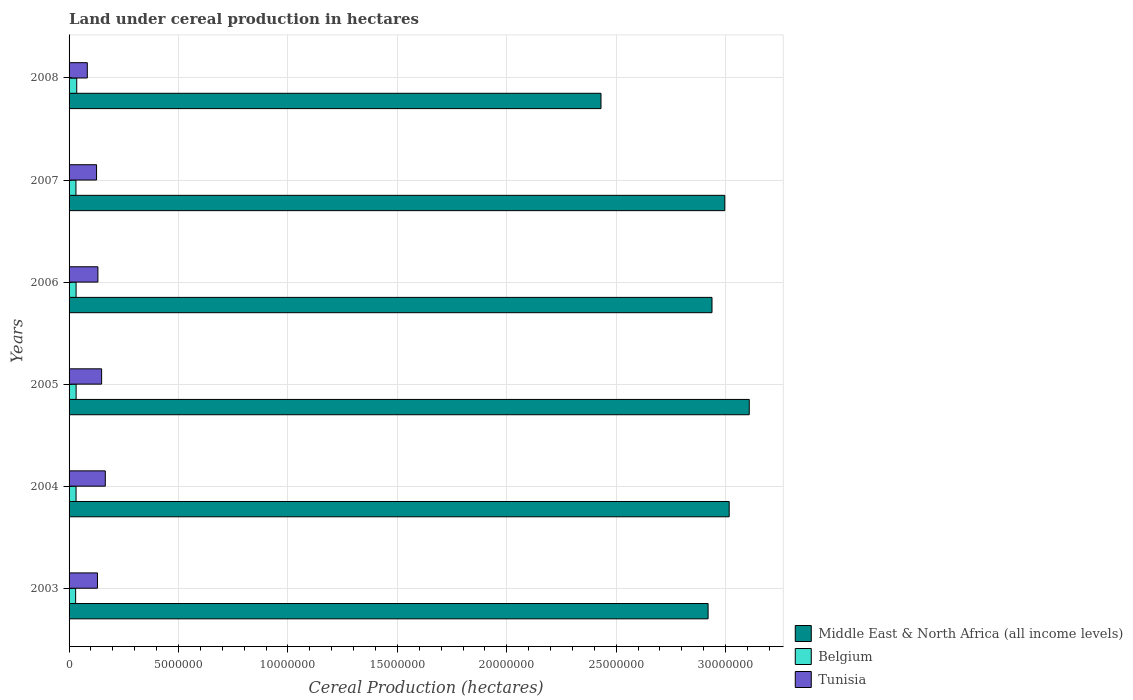Are the number of bars per tick equal to the number of legend labels?
Keep it short and to the point. Yes. Are the number of bars on each tick of the Y-axis equal?
Your response must be concise. Yes. How many bars are there on the 6th tick from the top?
Offer a terse response. 3. How many bars are there on the 4th tick from the bottom?
Keep it short and to the point. 3. What is the label of the 6th group of bars from the top?
Offer a very short reply. 2003. What is the land under cereal production in Middle East & North Africa (all income levels) in 2005?
Your response must be concise. 3.11e+07. Across all years, what is the maximum land under cereal production in Middle East & North Africa (all income levels)?
Provide a short and direct response. 3.11e+07. Across all years, what is the minimum land under cereal production in Middle East & North Africa (all income levels)?
Provide a short and direct response. 2.43e+07. In which year was the land under cereal production in Middle East & North Africa (all income levels) maximum?
Give a very brief answer. 2005. In which year was the land under cereal production in Tunisia minimum?
Offer a very short reply. 2008. What is the total land under cereal production in Tunisia in the graph?
Ensure brevity in your answer.  7.85e+06. What is the difference between the land under cereal production in Tunisia in 2007 and that in 2008?
Provide a succinct answer. 4.22e+05. What is the difference between the land under cereal production in Middle East & North Africa (all income levels) in 2004 and the land under cereal production in Tunisia in 2007?
Your answer should be very brief. 2.89e+07. What is the average land under cereal production in Middle East & North Africa (all income levels) per year?
Your response must be concise. 2.90e+07. In the year 2006, what is the difference between the land under cereal production in Tunisia and land under cereal production in Belgium?
Offer a terse response. 9.97e+05. In how many years, is the land under cereal production in Tunisia greater than 27000000 hectares?
Make the answer very short. 0. What is the ratio of the land under cereal production in Belgium in 2003 to that in 2007?
Provide a short and direct response. 0.95. Is the land under cereal production in Belgium in 2004 less than that in 2008?
Keep it short and to the point. Yes. Is the difference between the land under cereal production in Tunisia in 2003 and 2004 greater than the difference between the land under cereal production in Belgium in 2003 and 2004?
Provide a short and direct response. No. What is the difference between the highest and the second highest land under cereal production in Middle East & North Africa (all income levels)?
Give a very brief answer. 9.17e+05. What is the difference between the highest and the lowest land under cereal production in Middle East & North Africa (all income levels)?
Ensure brevity in your answer.  6.77e+06. Is the sum of the land under cereal production in Middle East & North Africa (all income levels) in 2004 and 2006 greater than the maximum land under cereal production in Belgium across all years?
Ensure brevity in your answer.  Yes. What does the 1st bar from the top in 2003 represents?
Offer a very short reply. Tunisia. What does the 3rd bar from the bottom in 2006 represents?
Offer a terse response. Tunisia. Is it the case that in every year, the sum of the land under cereal production in Middle East & North Africa (all income levels) and land under cereal production in Belgium is greater than the land under cereal production in Tunisia?
Make the answer very short. Yes. Are all the bars in the graph horizontal?
Provide a succinct answer. Yes. Does the graph contain any zero values?
Give a very brief answer. No. Does the graph contain grids?
Provide a succinct answer. Yes. What is the title of the graph?
Give a very brief answer. Land under cereal production in hectares. What is the label or title of the X-axis?
Provide a succinct answer. Cereal Production (hectares). What is the Cereal Production (hectares) of Middle East & North Africa (all income levels) in 2003?
Provide a succinct answer. 2.92e+07. What is the Cereal Production (hectares) in Belgium in 2003?
Offer a very short reply. 3.00e+05. What is the Cereal Production (hectares) in Tunisia in 2003?
Give a very brief answer. 1.30e+06. What is the Cereal Production (hectares) in Middle East & North Africa (all income levels) in 2004?
Provide a short and direct response. 3.02e+07. What is the Cereal Production (hectares) in Belgium in 2004?
Offer a very short reply. 3.19e+05. What is the Cereal Production (hectares) in Tunisia in 2004?
Provide a succinct answer. 1.65e+06. What is the Cereal Production (hectares) in Middle East & North Africa (all income levels) in 2005?
Your answer should be very brief. 3.11e+07. What is the Cereal Production (hectares) in Belgium in 2005?
Your response must be concise. 3.22e+05. What is the Cereal Production (hectares) of Tunisia in 2005?
Offer a very short reply. 1.49e+06. What is the Cereal Production (hectares) in Middle East & North Africa (all income levels) in 2006?
Provide a short and direct response. 2.94e+07. What is the Cereal Production (hectares) in Belgium in 2006?
Ensure brevity in your answer.  3.21e+05. What is the Cereal Production (hectares) of Tunisia in 2006?
Your answer should be compact. 1.32e+06. What is the Cereal Production (hectares) of Middle East & North Africa (all income levels) in 2007?
Your answer should be very brief. 3.00e+07. What is the Cereal Production (hectares) in Belgium in 2007?
Make the answer very short. 3.15e+05. What is the Cereal Production (hectares) of Tunisia in 2007?
Keep it short and to the point. 1.26e+06. What is the Cereal Production (hectares) of Middle East & North Africa (all income levels) in 2008?
Your answer should be very brief. 2.43e+07. What is the Cereal Production (hectares) of Belgium in 2008?
Your answer should be compact. 3.50e+05. What is the Cereal Production (hectares) of Tunisia in 2008?
Give a very brief answer. 8.34e+05. Across all years, what is the maximum Cereal Production (hectares) in Middle East & North Africa (all income levels)?
Ensure brevity in your answer.  3.11e+07. Across all years, what is the maximum Cereal Production (hectares) of Belgium?
Ensure brevity in your answer.  3.50e+05. Across all years, what is the maximum Cereal Production (hectares) in Tunisia?
Your answer should be very brief. 1.65e+06. Across all years, what is the minimum Cereal Production (hectares) in Middle East & North Africa (all income levels)?
Your answer should be very brief. 2.43e+07. Across all years, what is the minimum Cereal Production (hectares) in Belgium?
Your answer should be very brief. 3.00e+05. Across all years, what is the minimum Cereal Production (hectares) in Tunisia?
Provide a short and direct response. 8.34e+05. What is the total Cereal Production (hectares) in Middle East & North Africa (all income levels) in the graph?
Give a very brief answer. 1.74e+08. What is the total Cereal Production (hectares) in Belgium in the graph?
Keep it short and to the point. 1.93e+06. What is the total Cereal Production (hectares) in Tunisia in the graph?
Give a very brief answer. 7.85e+06. What is the difference between the Cereal Production (hectares) of Middle East & North Africa (all income levels) in 2003 and that in 2004?
Offer a terse response. -9.64e+05. What is the difference between the Cereal Production (hectares) of Belgium in 2003 and that in 2004?
Provide a succinct answer. -1.90e+04. What is the difference between the Cereal Production (hectares) in Tunisia in 2003 and that in 2004?
Ensure brevity in your answer.  -3.57e+05. What is the difference between the Cereal Production (hectares) in Middle East & North Africa (all income levels) in 2003 and that in 2005?
Provide a short and direct response. -1.88e+06. What is the difference between the Cereal Production (hectares) of Belgium in 2003 and that in 2005?
Ensure brevity in your answer.  -2.20e+04. What is the difference between the Cereal Production (hectares) in Tunisia in 2003 and that in 2005?
Your response must be concise. -1.90e+05. What is the difference between the Cereal Production (hectares) of Middle East & North Africa (all income levels) in 2003 and that in 2006?
Your answer should be very brief. -1.78e+05. What is the difference between the Cereal Production (hectares) of Belgium in 2003 and that in 2006?
Make the answer very short. -2.04e+04. What is the difference between the Cereal Production (hectares) in Tunisia in 2003 and that in 2006?
Offer a terse response. -1.98e+04. What is the difference between the Cereal Production (hectares) of Middle East & North Africa (all income levels) in 2003 and that in 2007?
Your answer should be compact. -7.63e+05. What is the difference between the Cereal Production (hectares) in Belgium in 2003 and that in 2007?
Offer a terse response. -1.45e+04. What is the difference between the Cereal Production (hectares) of Tunisia in 2003 and that in 2007?
Give a very brief answer. 4.20e+04. What is the difference between the Cereal Production (hectares) of Middle East & North Africa (all income levels) in 2003 and that in 2008?
Give a very brief answer. 4.89e+06. What is the difference between the Cereal Production (hectares) of Belgium in 2003 and that in 2008?
Your response must be concise. -5.02e+04. What is the difference between the Cereal Production (hectares) in Tunisia in 2003 and that in 2008?
Ensure brevity in your answer.  4.64e+05. What is the difference between the Cereal Production (hectares) of Middle East & North Africa (all income levels) in 2004 and that in 2005?
Provide a succinct answer. -9.17e+05. What is the difference between the Cereal Production (hectares) of Belgium in 2004 and that in 2005?
Your response must be concise. -2948. What is the difference between the Cereal Production (hectares) of Tunisia in 2004 and that in 2005?
Your response must be concise. 1.68e+05. What is the difference between the Cereal Production (hectares) in Middle East & North Africa (all income levels) in 2004 and that in 2006?
Provide a succinct answer. 7.85e+05. What is the difference between the Cereal Production (hectares) in Belgium in 2004 and that in 2006?
Your response must be concise. -1352. What is the difference between the Cereal Production (hectares) in Tunisia in 2004 and that in 2006?
Your answer should be very brief. 3.37e+05. What is the difference between the Cereal Production (hectares) of Middle East & North Africa (all income levels) in 2004 and that in 2007?
Provide a succinct answer. 2.01e+05. What is the difference between the Cereal Production (hectares) in Belgium in 2004 and that in 2007?
Your response must be concise. 4467. What is the difference between the Cereal Production (hectares) in Tunisia in 2004 and that in 2007?
Provide a succinct answer. 3.99e+05. What is the difference between the Cereal Production (hectares) of Middle East & North Africa (all income levels) in 2004 and that in 2008?
Your answer should be compact. 5.86e+06. What is the difference between the Cereal Production (hectares) of Belgium in 2004 and that in 2008?
Offer a terse response. -3.11e+04. What is the difference between the Cereal Production (hectares) of Tunisia in 2004 and that in 2008?
Keep it short and to the point. 8.21e+05. What is the difference between the Cereal Production (hectares) of Middle East & North Africa (all income levels) in 2005 and that in 2006?
Provide a succinct answer. 1.70e+06. What is the difference between the Cereal Production (hectares) in Belgium in 2005 and that in 2006?
Provide a succinct answer. 1596. What is the difference between the Cereal Production (hectares) in Tunisia in 2005 and that in 2006?
Offer a very short reply. 1.70e+05. What is the difference between the Cereal Production (hectares) of Middle East & North Africa (all income levels) in 2005 and that in 2007?
Your response must be concise. 1.12e+06. What is the difference between the Cereal Production (hectares) in Belgium in 2005 and that in 2007?
Make the answer very short. 7415. What is the difference between the Cereal Production (hectares) of Tunisia in 2005 and that in 2007?
Provide a succinct answer. 2.31e+05. What is the difference between the Cereal Production (hectares) in Middle East & North Africa (all income levels) in 2005 and that in 2008?
Offer a very short reply. 6.77e+06. What is the difference between the Cereal Production (hectares) of Belgium in 2005 and that in 2008?
Give a very brief answer. -2.82e+04. What is the difference between the Cereal Production (hectares) of Tunisia in 2005 and that in 2008?
Provide a succinct answer. 6.54e+05. What is the difference between the Cereal Production (hectares) in Middle East & North Africa (all income levels) in 2006 and that in 2007?
Offer a very short reply. -5.85e+05. What is the difference between the Cereal Production (hectares) of Belgium in 2006 and that in 2007?
Keep it short and to the point. 5819. What is the difference between the Cereal Production (hectares) in Tunisia in 2006 and that in 2007?
Your response must be concise. 6.18e+04. What is the difference between the Cereal Production (hectares) in Middle East & North Africa (all income levels) in 2006 and that in 2008?
Ensure brevity in your answer.  5.07e+06. What is the difference between the Cereal Production (hectares) in Belgium in 2006 and that in 2008?
Your answer should be very brief. -2.98e+04. What is the difference between the Cereal Production (hectares) of Tunisia in 2006 and that in 2008?
Offer a very short reply. 4.84e+05. What is the difference between the Cereal Production (hectares) in Middle East & North Africa (all income levels) in 2007 and that in 2008?
Offer a very short reply. 5.66e+06. What is the difference between the Cereal Production (hectares) of Belgium in 2007 and that in 2008?
Your answer should be very brief. -3.56e+04. What is the difference between the Cereal Production (hectares) of Tunisia in 2007 and that in 2008?
Offer a very short reply. 4.22e+05. What is the difference between the Cereal Production (hectares) in Middle East & North Africa (all income levels) in 2003 and the Cereal Production (hectares) in Belgium in 2004?
Offer a very short reply. 2.89e+07. What is the difference between the Cereal Production (hectares) in Middle East & North Africa (all income levels) in 2003 and the Cereal Production (hectares) in Tunisia in 2004?
Your response must be concise. 2.75e+07. What is the difference between the Cereal Production (hectares) of Belgium in 2003 and the Cereal Production (hectares) of Tunisia in 2004?
Offer a very short reply. -1.35e+06. What is the difference between the Cereal Production (hectares) of Middle East & North Africa (all income levels) in 2003 and the Cereal Production (hectares) of Belgium in 2005?
Keep it short and to the point. 2.89e+07. What is the difference between the Cereal Production (hectares) in Middle East & North Africa (all income levels) in 2003 and the Cereal Production (hectares) in Tunisia in 2005?
Provide a short and direct response. 2.77e+07. What is the difference between the Cereal Production (hectares) in Belgium in 2003 and the Cereal Production (hectares) in Tunisia in 2005?
Your answer should be compact. -1.19e+06. What is the difference between the Cereal Production (hectares) of Middle East & North Africa (all income levels) in 2003 and the Cereal Production (hectares) of Belgium in 2006?
Ensure brevity in your answer.  2.89e+07. What is the difference between the Cereal Production (hectares) in Middle East & North Africa (all income levels) in 2003 and the Cereal Production (hectares) in Tunisia in 2006?
Offer a very short reply. 2.79e+07. What is the difference between the Cereal Production (hectares) in Belgium in 2003 and the Cereal Production (hectares) in Tunisia in 2006?
Ensure brevity in your answer.  -1.02e+06. What is the difference between the Cereal Production (hectares) in Middle East & North Africa (all income levels) in 2003 and the Cereal Production (hectares) in Belgium in 2007?
Provide a short and direct response. 2.89e+07. What is the difference between the Cereal Production (hectares) of Middle East & North Africa (all income levels) in 2003 and the Cereal Production (hectares) of Tunisia in 2007?
Give a very brief answer. 2.79e+07. What is the difference between the Cereal Production (hectares) in Belgium in 2003 and the Cereal Production (hectares) in Tunisia in 2007?
Provide a succinct answer. -9.56e+05. What is the difference between the Cereal Production (hectares) of Middle East & North Africa (all income levels) in 2003 and the Cereal Production (hectares) of Belgium in 2008?
Offer a very short reply. 2.88e+07. What is the difference between the Cereal Production (hectares) of Middle East & North Africa (all income levels) in 2003 and the Cereal Production (hectares) of Tunisia in 2008?
Keep it short and to the point. 2.84e+07. What is the difference between the Cereal Production (hectares) in Belgium in 2003 and the Cereal Production (hectares) in Tunisia in 2008?
Your answer should be very brief. -5.33e+05. What is the difference between the Cereal Production (hectares) in Middle East & North Africa (all income levels) in 2004 and the Cereal Production (hectares) in Belgium in 2005?
Your answer should be compact. 2.98e+07. What is the difference between the Cereal Production (hectares) of Middle East & North Africa (all income levels) in 2004 and the Cereal Production (hectares) of Tunisia in 2005?
Give a very brief answer. 2.87e+07. What is the difference between the Cereal Production (hectares) in Belgium in 2004 and the Cereal Production (hectares) in Tunisia in 2005?
Give a very brief answer. -1.17e+06. What is the difference between the Cereal Production (hectares) in Middle East & North Africa (all income levels) in 2004 and the Cereal Production (hectares) in Belgium in 2006?
Ensure brevity in your answer.  2.98e+07. What is the difference between the Cereal Production (hectares) in Middle East & North Africa (all income levels) in 2004 and the Cereal Production (hectares) in Tunisia in 2006?
Keep it short and to the point. 2.88e+07. What is the difference between the Cereal Production (hectares) in Belgium in 2004 and the Cereal Production (hectares) in Tunisia in 2006?
Make the answer very short. -9.98e+05. What is the difference between the Cereal Production (hectares) in Middle East & North Africa (all income levels) in 2004 and the Cereal Production (hectares) in Belgium in 2007?
Keep it short and to the point. 2.98e+07. What is the difference between the Cereal Production (hectares) of Middle East & North Africa (all income levels) in 2004 and the Cereal Production (hectares) of Tunisia in 2007?
Give a very brief answer. 2.89e+07. What is the difference between the Cereal Production (hectares) in Belgium in 2004 and the Cereal Production (hectares) in Tunisia in 2007?
Ensure brevity in your answer.  -9.37e+05. What is the difference between the Cereal Production (hectares) in Middle East & North Africa (all income levels) in 2004 and the Cereal Production (hectares) in Belgium in 2008?
Your answer should be very brief. 2.98e+07. What is the difference between the Cereal Production (hectares) of Middle East & North Africa (all income levels) in 2004 and the Cereal Production (hectares) of Tunisia in 2008?
Make the answer very short. 2.93e+07. What is the difference between the Cereal Production (hectares) of Belgium in 2004 and the Cereal Production (hectares) of Tunisia in 2008?
Ensure brevity in your answer.  -5.14e+05. What is the difference between the Cereal Production (hectares) of Middle East & North Africa (all income levels) in 2005 and the Cereal Production (hectares) of Belgium in 2006?
Provide a succinct answer. 3.08e+07. What is the difference between the Cereal Production (hectares) of Middle East & North Africa (all income levels) in 2005 and the Cereal Production (hectares) of Tunisia in 2006?
Offer a very short reply. 2.98e+07. What is the difference between the Cereal Production (hectares) in Belgium in 2005 and the Cereal Production (hectares) in Tunisia in 2006?
Offer a terse response. -9.96e+05. What is the difference between the Cereal Production (hectares) in Middle East & North Africa (all income levels) in 2005 and the Cereal Production (hectares) in Belgium in 2007?
Keep it short and to the point. 3.08e+07. What is the difference between the Cereal Production (hectares) of Middle East & North Africa (all income levels) in 2005 and the Cereal Production (hectares) of Tunisia in 2007?
Your response must be concise. 2.98e+07. What is the difference between the Cereal Production (hectares) in Belgium in 2005 and the Cereal Production (hectares) in Tunisia in 2007?
Offer a terse response. -9.34e+05. What is the difference between the Cereal Production (hectares) in Middle East & North Africa (all income levels) in 2005 and the Cereal Production (hectares) in Belgium in 2008?
Provide a succinct answer. 3.07e+07. What is the difference between the Cereal Production (hectares) of Middle East & North Africa (all income levels) in 2005 and the Cereal Production (hectares) of Tunisia in 2008?
Your answer should be very brief. 3.02e+07. What is the difference between the Cereal Production (hectares) in Belgium in 2005 and the Cereal Production (hectares) in Tunisia in 2008?
Your answer should be very brief. -5.12e+05. What is the difference between the Cereal Production (hectares) of Middle East & North Africa (all income levels) in 2006 and the Cereal Production (hectares) of Belgium in 2007?
Offer a very short reply. 2.91e+07. What is the difference between the Cereal Production (hectares) of Middle East & North Africa (all income levels) in 2006 and the Cereal Production (hectares) of Tunisia in 2007?
Your answer should be very brief. 2.81e+07. What is the difference between the Cereal Production (hectares) of Belgium in 2006 and the Cereal Production (hectares) of Tunisia in 2007?
Your answer should be compact. -9.35e+05. What is the difference between the Cereal Production (hectares) of Middle East & North Africa (all income levels) in 2006 and the Cereal Production (hectares) of Belgium in 2008?
Provide a succinct answer. 2.90e+07. What is the difference between the Cereal Production (hectares) in Middle East & North Africa (all income levels) in 2006 and the Cereal Production (hectares) in Tunisia in 2008?
Provide a succinct answer. 2.85e+07. What is the difference between the Cereal Production (hectares) in Belgium in 2006 and the Cereal Production (hectares) in Tunisia in 2008?
Provide a short and direct response. -5.13e+05. What is the difference between the Cereal Production (hectares) of Middle East & North Africa (all income levels) in 2007 and the Cereal Production (hectares) of Belgium in 2008?
Offer a very short reply. 2.96e+07. What is the difference between the Cereal Production (hectares) in Middle East & North Africa (all income levels) in 2007 and the Cereal Production (hectares) in Tunisia in 2008?
Offer a terse response. 2.91e+07. What is the difference between the Cereal Production (hectares) in Belgium in 2007 and the Cereal Production (hectares) in Tunisia in 2008?
Your response must be concise. -5.19e+05. What is the average Cereal Production (hectares) in Middle East & North Africa (all income levels) per year?
Offer a very short reply. 2.90e+07. What is the average Cereal Production (hectares) in Belgium per year?
Keep it short and to the point. 3.21e+05. What is the average Cereal Production (hectares) of Tunisia per year?
Provide a short and direct response. 1.31e+06. In the year 2003, what is the difference between the Cereal Production (hectares) of Middle East & North Africa (all income levels) and Cereal Production (hectares) of Belgium?
Your answer should be very brief. 2.89e+07. In the year 2003, what is the difference between the Cereal Production (hectares) in Middle East & North Africa (all income levels) and Cereal Production (hectares) in Tunisia?
Offer a terse response. 2.79e+07. In the year 2003, what is the difference between the Cereal Production (hectares) in Belgium and Cereal Production (hectares) in Tunisia?
Provide a short and direct response. -9.98e+05. In the year 2004, what is the difference between the Cereal Production (hectares) of Middle East & North Africa (all income levels) and Cereal Production (hectares) of Belgium?
Make the answer very short. 2.98e+07. In the year 2004, what is the difference between the Cereal Production (hectares) in Middle East & North Africa (all income levels) and Cereal Production (hectares) in Tunisia?
Ensure brevity in your answer.  2.85e+07. In the year 2004, what is the difference between the Cereal Production (hectares) of Belgium and Cereal Production (hectares) of Tunisia?
Provide a short and direct response. -1.34e+06. In the year 2005, what is the difference between the Cereal Production (hectares) in Middle East & North Africa (all income levels) and Cereal Production (hectares) in Belgium?
Provide a short and direct response. 3.08e+07. In the year 2005, what is the difference between the Cereal Production (hectares) of Middle East & North Africa (all income levels) and Cereal Production (hectares) of Tunisia?
Your answer should be compact. 2.96e+07. In the year 2005, what is the difference between the Cereal Production (hectares) of Belgium and Cereal Production (hectares) of Tunisia?
Make the answer very short. -1.17e+06. In the year 2006, what is the difference between the Cereal Production (hectares) in Middle East & North Africa (all income levels) and Cereal Production (hectares) in Belgium?
Your answer should be compact. 2.91e+07. In the year 2006, what is the difference between the Cereal Production (hectares) in Middle East & North Africa (all income levels) and Cereal Production (hectares) in Tunisia?
Keep it short and to the point. 2.81e+07. In the year 2006, what is the difference between the Cereal Production (hectares) of Belgium and Cereal Production (hectares) of Tunisia?
Your answer should be compact. -9.97e+05. In the year 2007, what is the difference between the Cereal Production (hectares) in Middle East & North Africa (all income levels) and Cereal Production (hectares) in Belgium?
Ensure brevity in your answer.  2.96e+07. In the year 2007, what is the difference between the Cereal Production (hectares) in Middle East & North Africa (all income levels) and Cereal Production (hectares) in Tunisia?
Provide a short and direct response. 2.87e+07. In the year 2007, what is the difference between the Cereal Production (hectares) in Belgium and Cereal Production (hectares) in Tunisia?
Your answer should be compact. -9.41e+05. In the year 2008, what is the difference between the Cereal Production (hectares) in Middle East & North Africa (all income levels) and Cereal Production (hectares) in Belgium?
Your answer should be compact. 2.40e+07. In the year 2008, what is the difference between the Cereal Production (hectares) of Middle East & North Africa (all income levels) and Cereal Production (hectares) of Tunisia?
Offer a very short reply. 2.35e+07. In the year 2008, what is the difference between the Cereal Production (hectares) of Belgium and Cereal Production (hectares) of Tunisia?
Your answer should be very brief. -4.83e+05. What is the ratio of the Cereal Production (hectares) in Middle East & North Africa (all income levels) in 2003 to that in 2004?
Your response must be concise. 0.97. What is the ratio of the Cereal Production (hectares) of Belgium in 2003 to that in 2004?
Provide a succinct answer. 0.94. What is the ratio of the Cereal Production (hectares) of Tunisia in 2003 to that in 2004?
Your answer should be compact. 0.78. What is the ratio of the Cereal Production (hectares) of Middle East & North Africa (all income levels) in 2003 to that in 2005?
Offer a terse response. 0.94. What is the ratio of the Cereal Production (hectares) in Belgium in 2003 to that in 2005?
Give a very brief answer. 0.93. What is the ratio of the Cereal Production (hectares) of Tunisia in 2003 to that in 2005?
Provide a succinct answer. 0.87. What is the ratio of the Cereal Production (hectares) of Middle East & North Africa (all income levels) in 2003 to that in 2006?
Your answer should be very brief. 0.99. What is the ratio of the Cereal Production (hectares) of Belgium in 2003 to that in 2006?
Your answer should be compact. 0.94. What is the ratio of the Cereal Production (hectares) of Tunisia in 2003 to that in 2006?
Offer a terse response. 0.98. What is the ratio of the Cereal Production (hectares) in Middle East & North Africa (all income levels) in 2003 to that in 2007?
Give a very brief answer. 0.97. What is the ratio of the Cereal Production (hectares) of Belgium in 2003 to that in 2007?
Your answer should be compact. 0.95. What is the ratio of the Cereal Production (hectares) in Tunisia in 2003 to that in 2007?
Keep it short and to the point. 1.03. What is the ratio of the Cereal Production (hectares) in Middle East & North Africa (all income levels) in 2003 to that in 2008?
Your answer should be very brief. 1.2. What is the ratio of the Cereal Production (hectares) of Belgium in 2003 to that in 2008?
Your answer should be compact. 0.86. What is the ratio of the Cereal Production (hectares) of Tunisia in 2003 to that in 2008?
Provide a short and direct response. 1.56. What is the ratio of the Cereal Production (hectares) of Middle East & North Africa (all income levels) in 2004 to that in 2005?
Keep it short and to the point. 0.97. What is the ratio of the Cereal Production (hectares) of Tunisia in 2004 to that in 2005?
Your answer should be very brief. 1.11. What is the ratio of the Cereal Production (hectares) in Middle East & North Africa (all income levels) in 2004 to that in 2006?
Your answer should be very brief. 1.03. What is the ratio of the Cereal Production (hectares) of Tunisia in 2004 to that in 2006?
Provide a short and direct response. 1.26. What is the ratio of the Cereal Production (hectares) in Middle East & North Africa (all income levels) in 2004 to that in 2007?
Offer a terse response. 1.01. What is the ratio of the Cereal Production (hectares) in Belgium in 2004 to that in 2007?
Your answer should be compact. 1.01. What is the ratio of the Cereal Production (hectares) in Tunisia in 2004 to that in 2007?
Ensure brevity in your answer.  1.32. What is the ratio of the Cereal Production (hectares) of Middle East & North Africa (all income levels) in 2004 to that in 2008?
Make the answer very short. 1.24. What is the ratio of the Cereal Production (hectares) of Belgium in 2004 to that in 2008?
Give a very brief answer. 0.91. What is the ratio of the Cereal Production (hectares) in Tunisia in 2004 to that in 2008?
Your answer should be compact. 1.99. What is the ratio of the Cereal Production (hectares) in Middle East & North Africa (all income levels) in 2005 to that in 2006?
Your response must be concise. 1.06. What is the ratio of the Cereal Production (hectares) of Belgium in 2005 to that in 2006?
Keep it short and to the point. 1. What is the ratio of the Cereal Production (hectares) of Tunisia in 2005 to that in 2006?
Your answer should be compact. 1.13. What is the ratio of the Cereal Production (hectares) in Middle East & North Africa (all income levels) in 2005 to that in 2007?
Give a very brief answer. 1.04. What is the ratio of the Cereal Production (hectares) in Belgium in 2005 to that in 2007?
Offer a terse response. 1.02. What is the ratio of the Cereal Production (hectares) in Tunisia in 2005 to that in 2007?
Your answer should be compact. 1.18. What is the ratio of the Cereal Production (hectares) in Middle East & North Africa (all income levels) in 2005 to that in 2008?
Keep it short and to the point. 1.28. What is the ratio of the Cereal Production (hectares) of Belgium in 2005 to that in 2008?
Your response must be concise. 0.92. What is the ratio of the Cereal Production (hectares) of Tunisia in 2005 to that in 2008?
Your answer should be compact. 1.78. What is the ratio of the Cereal Production (hectares) of Middle East & North Africa (all income levels) in 2006 to that in 2007?
Provide a short and direct response. 0.98. What is the ratio of the Cereal Production (hectares) in Belgium in 2006 to that in 2007?
Offer a very short reply. 1.02. What is the ratio of the Cereal Production (hectares) of Tunisia in 2006 to that in 2007?
Keep it short and to the point. 1.05. What is the ratio of the Cereal Production (hectares) of Middle East & North Africa (all income levels) in 2006 to that in 2008?
Your response must be concise. 1.21. What is the ratio of the Cereal Production (hectares) in Belgium in 2006 to that in 2008?
Your answer should be compact. 0.92. What is the ratio of the Cereal Production (hectares) of Tunisia in 2006 to that in 2008?
Give a very brief answer. 1.58. What is the ratio of the Cereal Production (hectares) of Middle East & North Africa (all income levels) in 2007 to that in 2008?
Offer a terse response. 1.23. What is the ratio of the Cereal Production (hectares) in Belgium in 2007 to that in 2008?
Your answer should be very brief. 0.9. What is the ratio of the Cereal Production (hectares) in Tunisia in 2007 to that in 2008?
Keep it short and to the point. 1.51. What is the difference between the highest and the second highest Cereal Production (hectares) in Middle East & North Africa (all income levels)?
Give a very brief answer. 9.17e+05. What is the difference between the highest and the second highest Cereal Production (hectares) of Belgium?
Make the answer very short. 2.82e+04. What is the difference between the highest and the second highest Cereal Production (hectares) in Tunisia?
Provide a succinct answer. 1.68e+05. What is the difference between the highest and the lowest Cereal Production (hectares) in Middle East & North Africa (all income levels)?
Your answer should be very brief. 6.77e+06. What is the difference between the highest and the lowest Cereal Production (hectares) of Belgium?
Offer a very short reply. 5.02e+04. What is the difference between the highest and the lowest Cereal Production (hectares) in Tunisia?
Provide a short and direct response. 8.21e+05. 